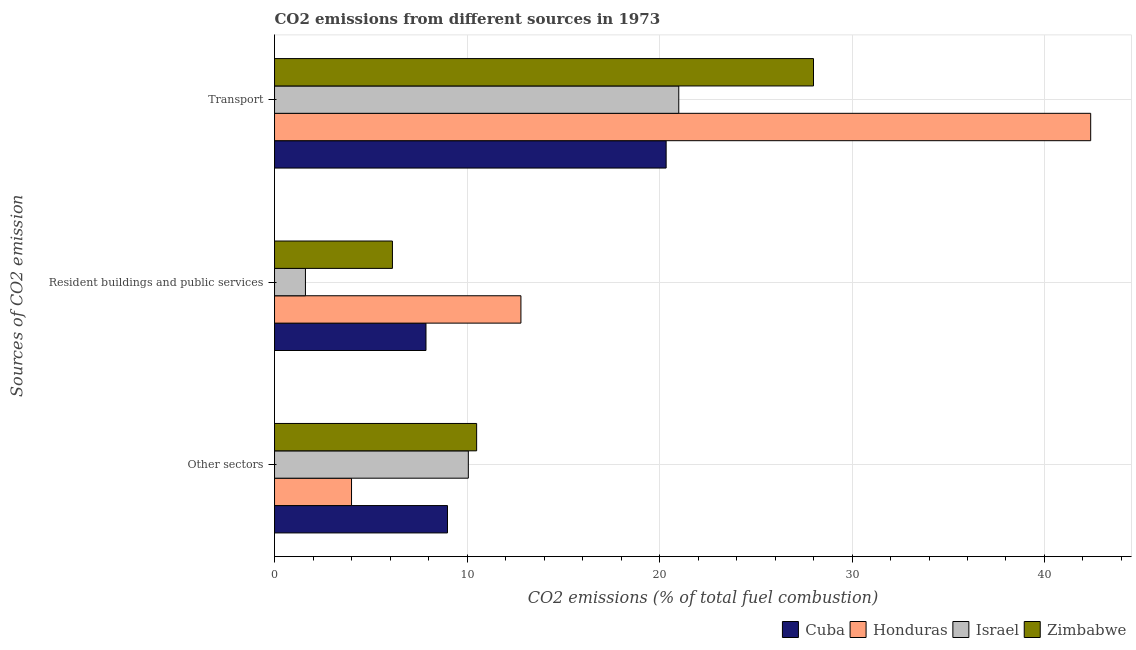How many different coloured bars are there?
Your answer should be very brief. 4. Are the number of bars on each tick of the Y-axis equal?
Ensure brevity in your answer.  Yes. What is the label of the 3rd group of bars from the top?
Give a very brief answer. Other sectors. Across all countries, what is the maximum percentage of co2 emissions from transport?
Make the answer very short. 42.4. Across all countries, what is the minimum percentage of co2 emissions from other sectors?
Make the answer very short. 4. In which country was the percentage of co2 emissions from transport maximum?
Your answer should be compact. Honduras. What is the total percentage of co2 emissions from other sectors in the graph?
Keep it short and to the point. 33.55. What is the difference between the percentage of co2 emissions from other sectors in Zimbabwe and that in Israel?
Provide a succinct answer. 0.43. What is the difference between the percentage of co2 emissions from transport in Israel and the percentage of co2 emissions from other sectors in Honduras?
Offer a very short reply. 17. What is the average percentage of co2 emissions from other sectors per country?
Ensure brevity in your answer.  8.39. What is the difference between the percentage of co2 emissions from transport and percentage of co2 emissions from resident buildings and public services in Honduras?
Provide a succinct answer. 29.6. What is the ratio of the percentage of co2 emissions from other sectors in Israel to that in Cuba?
Offer a terse response. 1.12. Is the percentage of co2 emissions from resident buildings and public services in Honduras less than that in Zimbabwe?
Offer a very short reply. No. What is the difference between the highest and the second highest percentage of co2 emissions from other sectors?
Make the answer very short. 0.43. What is the difference between the highest and the lowest percentage of co2 emissions from resident buildings and public services?
Offer a very short reply. 11.19. In how many countries, is the percentage of co2 emissions from other sectors greater than the average percentage of co2 emissions from other sectors taken over all countries?
Provide a succinct answer. 3. What does the 2nd bar from the top in Resident buildings and public services represents?
Make the answer very short. Israel. What does the 1st bar from the bottom in Transport represents?
Ensure brevity in your answer.  Cuba. How many bars are there?
Keep it short and to the point. 12. How many countries are there in the graph?
Offer a very short reply. 4. Are the values on the major ticks of X-axis written in scientific E-notation?
Ensure brevity in your answer.  No. Does the graph contain any zero values?
Keep it short and to the point. No. Does the graph contain grids?
Keep it short and to the point. Yes. How are the legend labels stacked?
Offer a very short reply. Horizontal. What is the title of the graph?
Your response must be concise. CO2 emissions from different sources in 1973. Does "Zambia" appear as one of the legend labels in the graph?
Offer a very short reply. No. What is the label or title of the X-axis?
Offer a very short reply. CO2 emissions (% of total fuel combustion). What is the label or title of the Y-axis?
Make the answer very short. Sources of CO2 emission. What is the CO2 emissions (% of total fuel combustion) of Cuba in Other sectors?
Offer a terse response. 8.99. What is the CO2 emissions (% of total fuel combustion) in Honduras in Other sectors?
Offer a very short reply. 4. What is the CO2 emissions (% of total fuel combustion) of Israel in Other sectors?
Your answer should be very brief. 10.07. What is the CO2 emissions (% of total fuel combustion) of Zimbabwe in Other sectors?
Provide a succinct answer. 10.5. What is the CO2 emissions (% of total fuel combustion) of Cuba in Resident buildings and public services?
Your response must be concise. 7.87. What is the CO2 emissions (% of total fuel combustion) in Israel in Resident buildings and public services?
Offer a terse response. 1.61. What is the CO2 emissions (% of total fuel combustion) in Zimbabwe in Resident buildings and public services?
Provide a succinct answer. 6.12. What is the CO2 emissions (% of total fuel combustion) in Cuba in Transport?
Offer a terse response. 20.34. What is the CO2 emissions (% of total fuel combustion) in Honduras in Transport?
Offer a very short reply. 42.4. What is the CO2 emissions (% of total fuel combustion) in Israel in Transport?
Your answer should be very brief. 21. Across all Sources of CO2 emission, what is the maximum CO2 emissions (% of total fuel combustion) of Cuba?
Offer a very short reply. 20.34. Across all Sources of CO2 emission, what is the maximum CO2 emissions (% of total fuel combustion) in Honduras?
Offer a very short reply. 42.4. Across all Sources of CO2 emission, what is the maximum CO2 emissions (% of total fuel combustion) of Israel?
Offer a very short reply. 21. Across all Sources of CO2 emission, what is the maximum CO2 emissions (% of total fuel combustion) of Zimbabwe?
Your response must be concise. 28. Across all Sources of CO2 emission, what is the minimum CO2 emissions (% of total fuel combustion) of Cuba?
Offer a very short reply. 7.87. Across all Sources of CO2 emission, what is the minimum CO2 emissions (% of total fuel combustion) of Israel?
Ensure brevity in your answer.  1.61. Across all Sources of CO2 emission, what is the minimum CO2 emissions (% of total fuel combustion) in Zimbabwe?
Your answer should be very brief. 6.12. What is the total CO2 emissions (% of total fuel combustion) of Cuba in the graph?
Keep it short and to the point. 37.2. What is the total CO2 emissions (% of total fuel combustion) in Honduras in the graph?
Provide a succinct answer. 59.2. What is the total CO2 emissions (% of total fuel combustion) of Israel in the graph?
Your response must be concise. 32.67. What is the total CO2 emissions (% of total fuel combustion) of Zimbabwe in the graph?
Ensure brevity in your answer.  44.62. What is the difference between the CO2 emissions (% of total fuel combustion) in Cuba in Other sectors and that in Resident buildings and public services?
Your answer should be very brief. 1.12. What is the difference between the CO2 emissions (% of total fuel combustion) in Israel in Other sectors and that in Resident buildings and public services?
Keep it short and to the point. 8.46. What is the difference between the CO2 emissions (% of total fuel combustion) in Zimbabwe in Other sectors and that in Resident buildings and public services?
Your answer should be compact. 4.38. What is the difference between the CO2 emissions (% of total fuel combustion) in Cuba in Other sectors and that in Transport?
Give a very brief answer. -11.36. What is the difference between the CO2 emissions (% of total fuel combustion) of Honduras in Other sectors and that in Transport?
Ensure brevity in your answer.  -38.4. What is the difference between the CO2 emissions (% of total fuel combustion) in Israel in Other sectors and that in Transport?
Ensure brevity in your answer.  -10.93. What is the difference between the CO2 emissions (% of total fuel combustion) in Zimbabwe in Other sectors and that in Transport?
Your answer should be compact. -17.5. What is the difference between the CO2 emissions (% of total fuel combustion) in Cuba in Resident buildings and public services and that in Transport?
Offer a terse response. -12.48. What is the difference between the CO2 emissions (% of total fuel combustion) of Honduras in Resident buildings and public services and that in Transport?
Ensure brevity in your answer.  -29.6. What is the difference between the CO2 emissions (% of total fuel combustion) of Israel in Resident buildings and public services and that in Transport?
Your answer should be compact. -19.39. What is the difference between the CO2 emissions (% of total fuel combustion) of Zimbabwe in Resident buildings and public services and that in Transport?
Provide a succinct answer. -21.88. What is the difference between the CO2 emissions (% of total fuel combustion) of Cuba in Other sectors and the CO2 emissions (% of total fuel combustion) of Honduras in Resident buildings and public services?
Provide a succinct answer. -3.81. What is the difference between the CO2 emissions (% of total fuel combustion) in Cuba in Other sectors and the CO2 emissions (% of total fuel combustion) in Israel in Resident buildings and public services?
Provide a short and direct response. 7.38. What is the difference between the CO2 emissions (% of total fuel combustion) in Cuba in Other sectors and the CO2 emissions (% of total fuel combustion) in Zimbabwe in Resident buildings and public services?
Keep it short and to the point. 2.86. What is the difference between the CO2 emissions (% of total fuel combustion) in Honduras in Other sectors and the CO2 emissions (% of total fuel combustion) in Israel in Resident buildings and public services?
Keep it short and to the point. 2.39. What is the difference between the CO2 emissions (% of total fuel combustion) of Honduras in Other sectors and the CO2 emissions (% of total fuel combustion) of Zimbabwe in Resident buildings and public services?
Your response must be concise. -2.12. What is the difference between the CO2 emissions (% of total fuel combustion) of Israel in Other sectors and the CO2 emissions (% of total fuel combustion) of Zimbabwe in Resident buildings and public services?
Offer a terse response. 3.94. What is the difference between the CO2 emissions (% of total fuel combustion) of Cuba in Other sectors and the CO2 emissions (% of total fuel combustion) of Honduras in Transport?
Make the answer very short. -33.41. What is the difference between the CO2 emissions (% of total fuel combustion) in Cuba in Other sectors and the CO2 emissions (% of total fuel combustion) in Israel in Transport?
Keep it short and to the point. -12.02. What is the difference between the CO2 emissions (% of total fuel combustion) of Cuba in Other sectors and the CO2 emissions (% of total fuel combustion) of Zimbabwe in Transport?
Your response must be concise. -19.01. What is the difference between the CO2 emissions (% of total fuel combustion) in Honduras in Other sectors and the CO2 emissions (% of total fuel combustion) in Israel in Transport?
Offer a very short reply. -17. What is the difference between the CO2 emissions (% of total fuel combustion) of Honduras in Other sectors and the CO2 emissions (% of total fuel combustion) of Zimbabwe in Transport?
Keep it short and to the point. -24. What is the difference between the CO2 emissions (% of total fuel combustion) of Israel in Other sectors and the CO2 emissions (% of total fuel combustion) of Zimbabwe in Transport?
Offer a very short reply. -17.93. What is the difference between the CO2 emissions (% of total fuel combustion) of Cuba in Resident buildings and public services and the CO2 emissions (% of total fuel combustion) of Honduras in Transport?
Your response must be concise. -34.53. What is the difference between the CO2 emissions (% of total fuel combustion) of Cuba in Resident buildings and public services and the CO2 emissions (% of total fuel combustion) of Israel in Transport?
Your answer should be compact. -13.13. What is the difference between the CO2 emissions (% of total fuel combustion) of Cuba in Resident buildings and public services and the CO2 emissions (% of total fuel combustion) of Zimbabwe in Transport?
Your answer should be very brief. -20.13. What is the difference between the CO2 emissions (% of total fuel combustion) in Honduras in Resident buildings and public services and the CO2 emissions (% of total fuel combustion) in Israel in Transport?
Provide a short and direct response. -8.2. What is the difference between the CO2 emissions (% of total fuel combustion) in Honduras in Resident buildings and public services and the CO2 emissions (% of total fuel combustion) in Zimbabwe in Transport?
Give a very brief answer. -15.2. What is the difference between the CO2 emissions (% of total fuel combustion) of Israel in Resident buildings and public services and the CO2 emissions (% of total fuel combustion) of Zimbabwe in Transport?
Offer a terse response. -26.39. What is the average CO2 emissions (% of total fuel combustion) of Cuba per Sources of CO2 emission?
Offer a terse response. 12.4. What is the average CO2 emissions (% of total fuel combustion) in Honduras per Sources of CO2 emission?
Your answer should be very brief. 19.73. What is the average CO2 emissions (% of total fuel combustion) of Israel per Sources of CO2 emission?
Keep it short and to the point. 10.89. What is the average CO2 emissions (% of total fuel combustion) of Zimbabwe per Sources of CO2 emission?
Give a very brief answer. 14.88. What is the difference between the CO2 emissions (% of total fuel combustion) of Cuba and CO2 emissions (% of total fuel combustion) of Honduras in Other sectors?
Provide a succinct answer. 4.99. What is the difference between the CO2 emissions (% of total fuel combustion) in Cuba and CO2 emissions (% of total fuel combustion) in Israel in Other sectors?
Offer a terse response. -1.08. What is the difference between the CO2 emissions (% of total fuel combustion) in Cuba and CO2 emissions (% of total fuel combustion) in Zimbabwe in Other sectors?
Offer a very short reply. -1.51. What is the difference between the CO2 emissions (% of total fuel combustion) of Honduras and CO2 emissions (% of total fuel combustion) of Israel in Other sectors?
Provide a short and direct response. -6.07. What is the difference between the CO2 emissions (% of total fuel combustion) in Israel and CO2 emissions (% of total fuel combustion) in Zimbabwe in Other sectors?
Provide a succinct answer. -0.43. What is the difference between the CO2 emissions (% of total fuel combustion) in Cuba and CO2 emissions (% of total fuel combustion) in Honduras in Resident buildings and public services?
Your answer should be compact. -4.93. What is the difference between the CO2 emissions (% of total fuel combustion) in Cuba and CO2 emissions (% of total fuel combustion) in Israel in Resident buildings and public services?
Give a very brief answer. 6.26. What is the difference between the CO2 emissions (% of total fuel combustion) of Cuba and CO2 emissions (% of total fuel combustion) of Zimbabwe in Resident buildings and public services?
Make the answer very short. 1.74. What is the difference between the CO2 emissions (% of total fuel combustion) of Honduras and CO2 emissions (% of total fuel combustion) of Israel in Resident buildings and public services?
Ensure brevity in your answer.  11.19. What is the difference between the CO2 emissions (% of total fuel combustion) in Honduras and CO2 emissions (% of total fuel combustion) in Zimbabwe in Resident buildings and public services?
Your answer should be very brief. 6.67. What is the difference between the CO2 emissions (% of total fuel combustion) of Israel and CO2 emissions (% of total fuel combustion) of Zimbabwe in Resident buildings and public services?
Ensure brevity in your answer.  -4.52. What is the difference between the CO2 emissions (% of total fuel combustion) in Cuba and CO2 emissions (% of total fuel combustion) in Honduras in Transport?
Your answer should be compact. -22.06. What is the difference between the CO2 emissions (% of total fuel combustion) in Cuba and CO2 emissions (% of total fuel combustion) in Israel in Transport?
Your response must be concise. -0.66. What is the difference between the CO2 emissions (% of total fuel combustion) in Cuba and CO2 emissions (% of total fuel combustion) in Zimbabwe in Transport?
Provide a short and direct response. -7.66. What is the difference between the CO2 emissions (% of total fuel combustion) of Honduras and CO2 emissions (% of total fuel combustion) of Israel in Transport?
Make the answer very short. 21.4. What is the difference between the CO2 emissions (% of total fuel combustion) of Honduras and CO2 emissions (% of total fuel combustion) of Zimbabwe in Transport?
Keep it short and to the point. 14.4. What is the difference between the CO2 emissions (% of total fuel combustion) of Israel and CO2 emissions (% of total fuel combustion) of Zimbabwe in Transport?
Offer a terse response. -7. What is the ratio of the CO2 emissions (% of total fuel combustion) of Cuba in Other sectors to that in Resident buildings and public services?
Your answer should be very brief. 1.14. What is the ratio of the CO2 emissions (% of total fuel combustion) in Honduras in Other sectors to that in Resident buildings and public services?
Offer a terse response. 0.31. What is the ratio of the CO2 emissions (% of total fuel combustion) in Israel in Other sectors to that in Resident buildings and public services?
Ensure brevity in your answer.  6.27. What is the ratio of the CO2 emissions (% of total fuel combustion) in Zimbabwe in Other sectors to that in Resident buildings and public services?
Your answer should be compact. 1.71. What is the ratio of the CO2 emissions (% of total fuel combustion) in Cuba in Other sectors to that in Transport?
Ensure brevity in your answer.  0.44. What is the ratio of the CO2 emissions (% of total fuel combustion) of Honduras in Other sectors to that in Transport?
Ensure brevity in your answer.  0.09. What is the ratio of the CO2 emissions (% of total fuel combustion) in Israel in Other sectors to that in Transport?
Ensure brevity in your answer.  0.48. What is the ratio of the CO2 emissions (% of total fuel combustion) in Cuba in Resident buildings and public services to that in Transport?
Provide a short and direct response. 0.39. What is the ratio of the CO2 emissions (% of total fuel combustion) of Honduras in Resident buildings and public services to that in Transport?
Give a very brief answer. 0.3. What is the ratio of the CO2 emissions (% of total fuel combustion) in Israel in Resident buildings and public services to that in Transport?
Offer a very short reply. 0.08. What is the ratio of the CO2 emissions (% of total fuel combustion) in Zimbabwe in Resident buildings and public services to that in Transport?
Provide a succinct answer. 0.22. What is the difference between the highest and the second highest CO2 emissions (% of total fuel combustion) in Cuba?
Provide a succinct answer. 11.36. What is the difference between the highest and the second highest CO2 emissions (% of total fuel combustion) of Honduras?
Your response must be concise. 29.6. What is the difference between the highest and the second highest CO2 emissions (% of total fuel combustion) in Israel?
Provide a succinct answer. 10.93. What is the difference between the highest and the lowest CO2 emissions (% of total fuel combustion) of Cuba?
Your answer should be compact. 12.48. What is the difference between the highest and the lowest CO2 emissions (% of total fuel combustion) in Honduras?
Ensure brevity in your answer.  38.4. What is the difference between the highest and the lowest CO2 emissions (% of total fuel combustion) in Israel?
Your answer should be compact. 19.39. What is the difference between the highest and the lowest CO2 emissions (% of total fuel combustion) in Zimbabwe?
Make the answer very short. 21.88. 